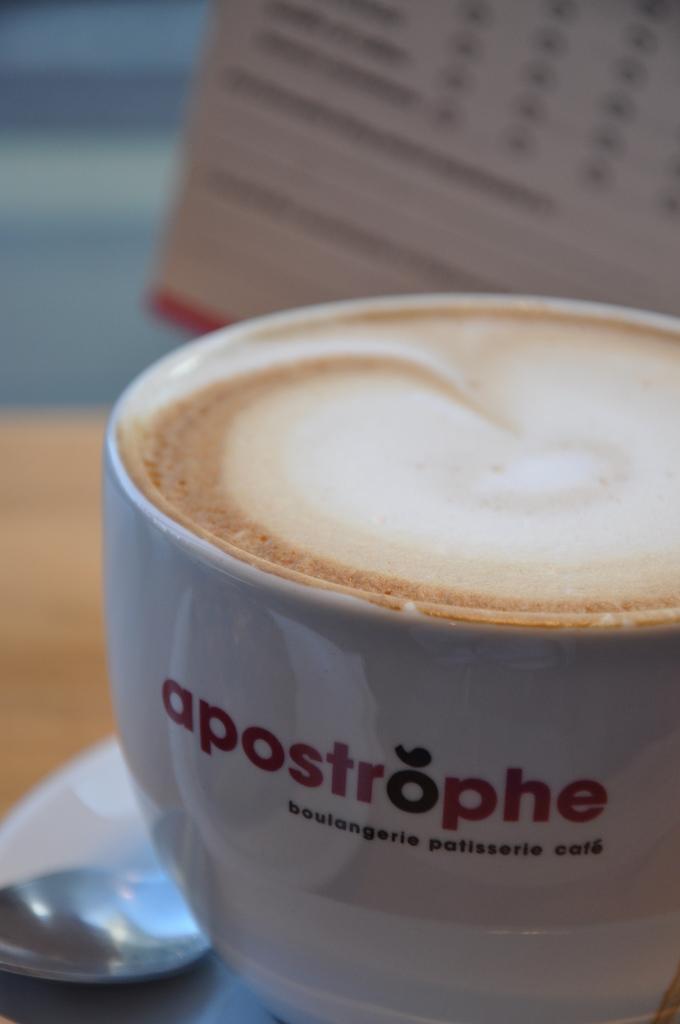How would you summarize this image in a sentence or two? Here we can see coffee in a cup,spoon are on a saucer on a platform. In the background the image is blur but we can see an object. 